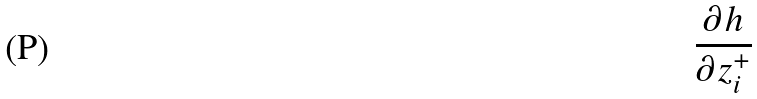Convert formula to latex. <formula><loc_0><loc_0><loc_500><loc_500>\frac { \partial h } { \partial z _ { i } ^ { + } }</formula> 